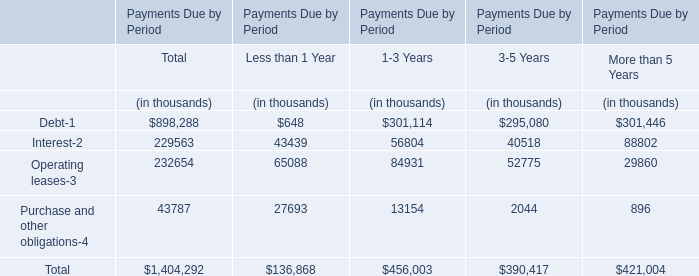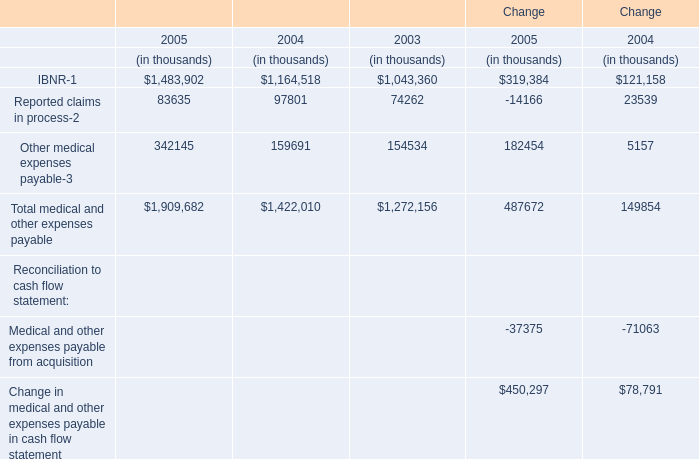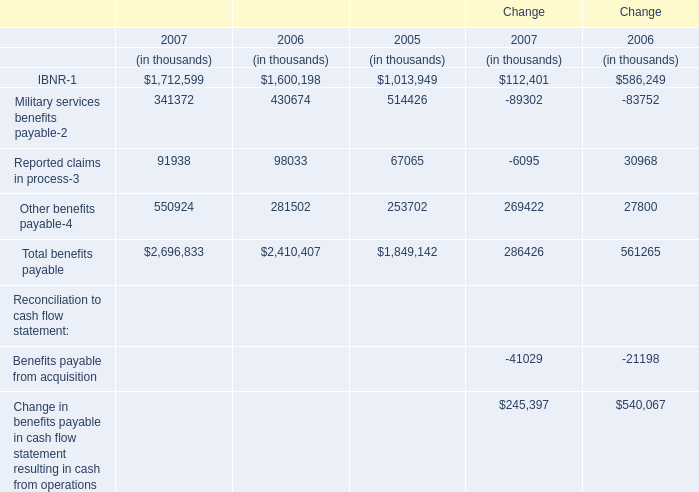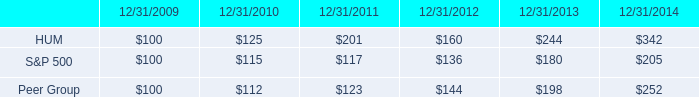What is the ratio of Other benefits payable-4 in Table 2 to the Other medical expenses payable-3 in Table 1 in 2005? 
Computations: (253702 / 342145)
Answer: 0.7415. 